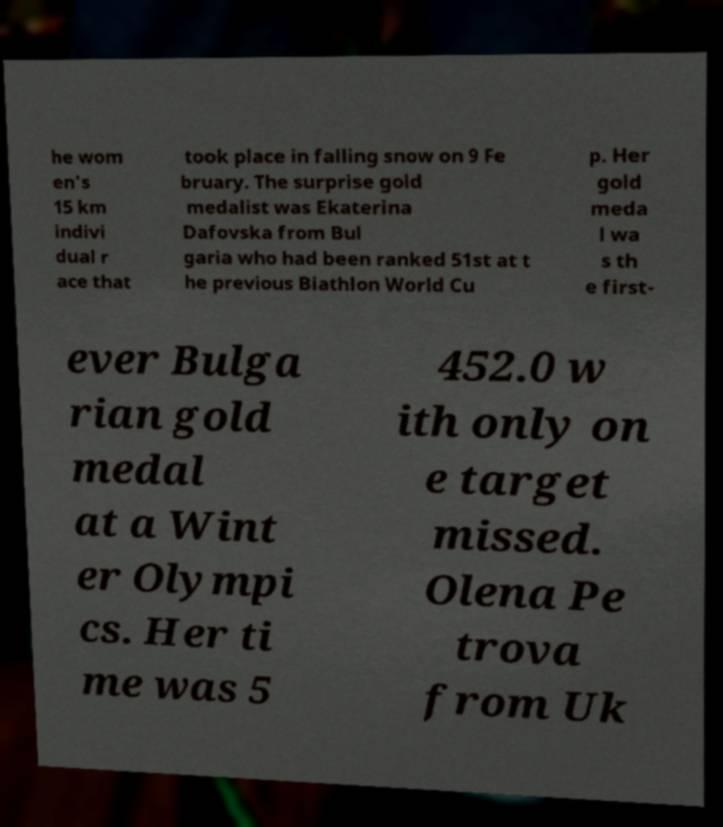Can you read and provide the text displayed in the image?This photo seems to have some interesting text. Can you extract and type it out for me? he wom en's 15 km indivi dual r ace that took place in falling snow on 9 Fe bruary. The surprise gold medalist was Ekaterina Dafovska from Bul garia who had been ranked 51st at t he previous Biathlon World Cu p. Her gold meda l wa s th e first- ever Bulga rian gold medal at a Wint er Olympi cs. Her ti me was 5 452.0 w ith only on e target missed. Olena Pe trova from Uk 